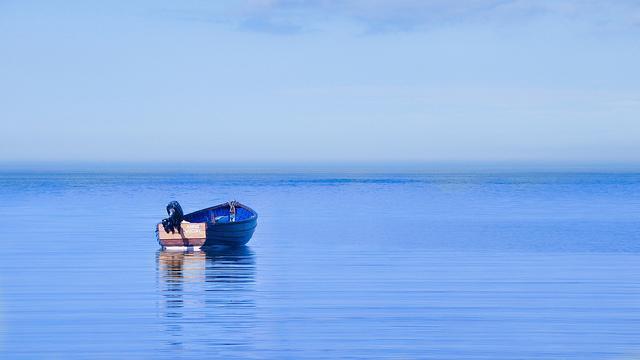How many boats are there?
Give a very brief answer. 1. How many people are wearing orange glasses?
Give a very brief answer. 0. 